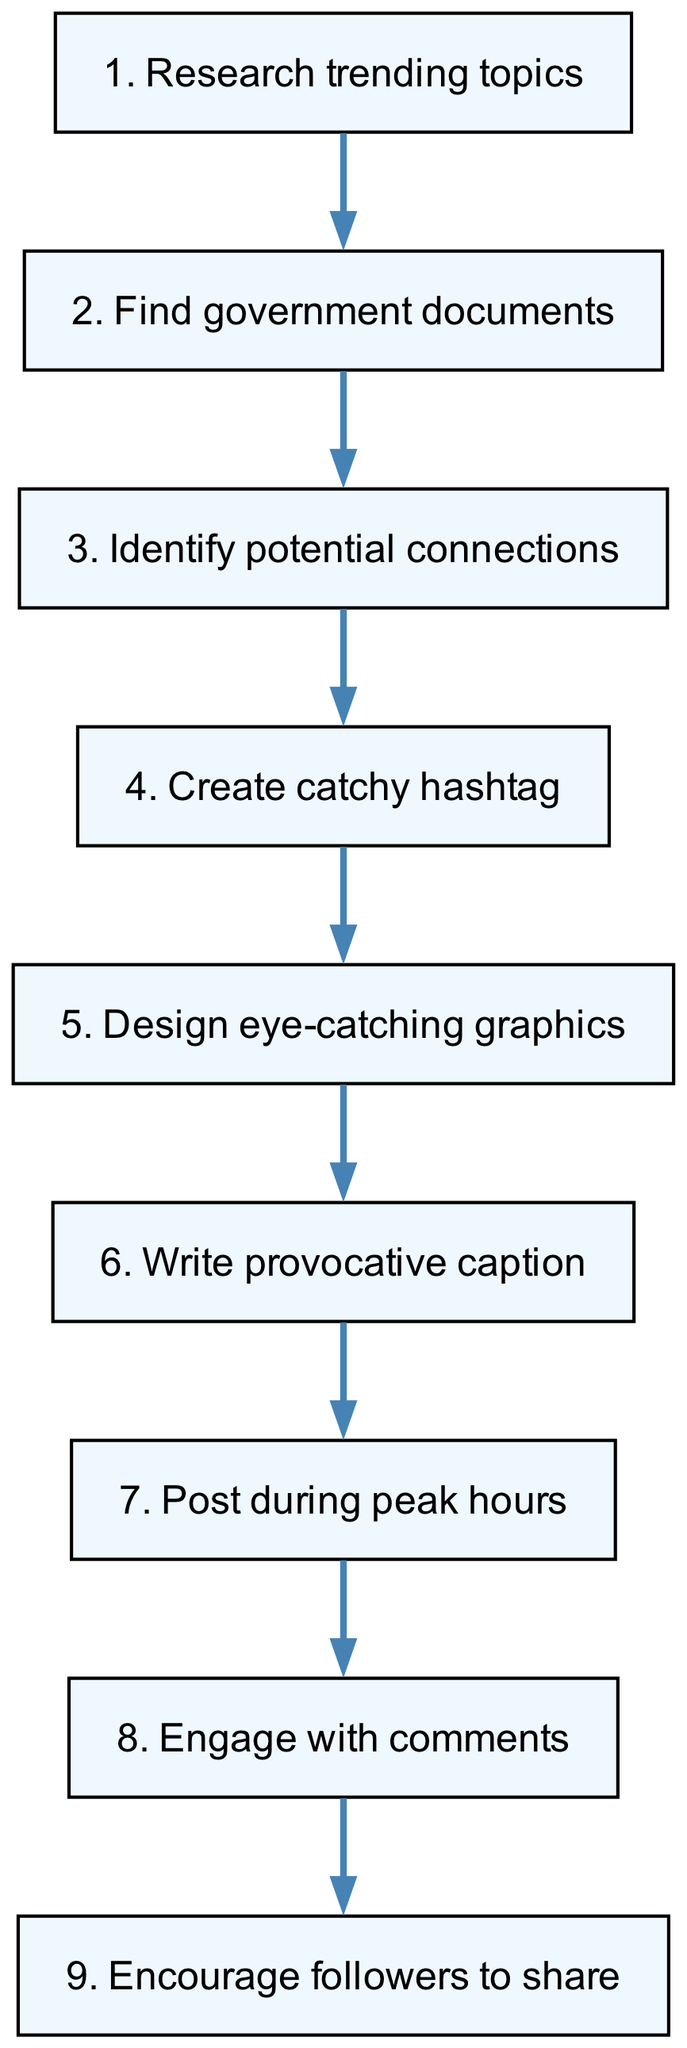What is the first step in the process? The diagram starts with the first node, which states "Research trending topics." This is the initial action in the flow chart.
Answer: Research trending topics How many total steps are there in the flow? Counting the nodes listed in the diagram, there are 9 steps in total.
Answer: 9 What is the final instruction in the process? The last node in the flow chart indicates to "Encourage followers to share," which is the final action to complete the process.
Answer: Encourage followers to share Which step follows the creation of the catchy hashtag? According to the flow chart, after "Create catchy hashtag," the next step is "Design eye-catching graphics." The edges show the connection between these two actions.
Answer: Design eye-catching graphics What is the third step in the process? The third step listed in the diagram is "Identify potential connections." This directly follows the initial research and document finding.
Answer: Identify potential connections What is the relationship between steps 4 and 5? Step 4 "Create catchy hashtag" leads directly to step 5 "Design eye-catching graphics," indicating a progression in the process where the catchy hashtag influences the graphic design.
Answer: Design eye-catching graphics What is the seventh step in the flow? The seventh step is "Post during peak hours," which is critical for maximizing audience engagement based on the timing of the post.
Answer: Post during peak hours Which step involves user interaction? The step "Engage with comments" is specifically about interacting with followers, making it essential for community building and feedback.
Answer: Engage with comments What step requires the analysis of potential connections? The node "Identify potential connections" specifically mentions the need to analyze relationships between findings, which is crucial in forming the conspiracy theory.
Answer: Identify potential connections 